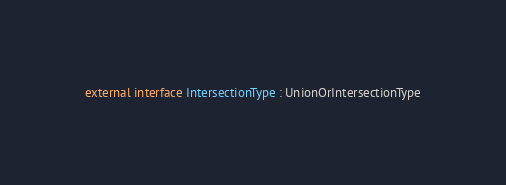Convert code to text. <code><loc_0><loc_0><loc_500><loc_500><_Kotlin_>
external interface IntersectionType : UnionOrIntersectionType
</code> 